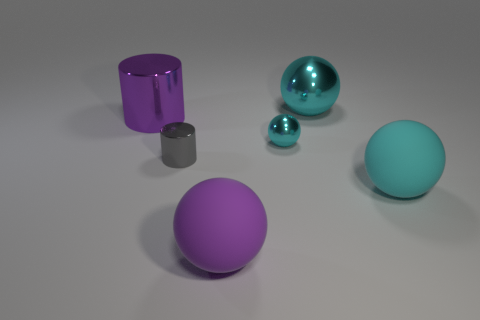What number of large purple things are both to the left of the gray object and in front of the cyan matte object?
Provide a succinct answer. 0. Do the cyan ball behind the purple cylinder and the gray metal object have the same size?
Give a very brief answer. No. Is there a shiny ball of the same color as the large cylinder?
Give a very brief answer. No. There is a purple object that is made of the same material as the gray object; what size is it?
Provide a short and direct response. Large. Is the number of tiny metallic objects behind the tiny gray cylinder greater than the number of matte balls in front of the large purple ball?
Your answer should be very brief. Yes. What number of other things are made of the same material as the big purple ball?
Make the answer very short. 1. Are the small thing on the right side of the large purple ball and the tiny gray thing made of the same material?
Give a very brief answer. Yes. What is the shape of the large purple metallic thing?
Provide a short and direct response. Cylinder. Are there more objects in front of the large purple shiny thing than tiny gray metallic cylinders?
Your response must be concise. Yes. Is there any other thing that has the same shape as the large purple matte thing?
Your answer should be compact. Yes. 